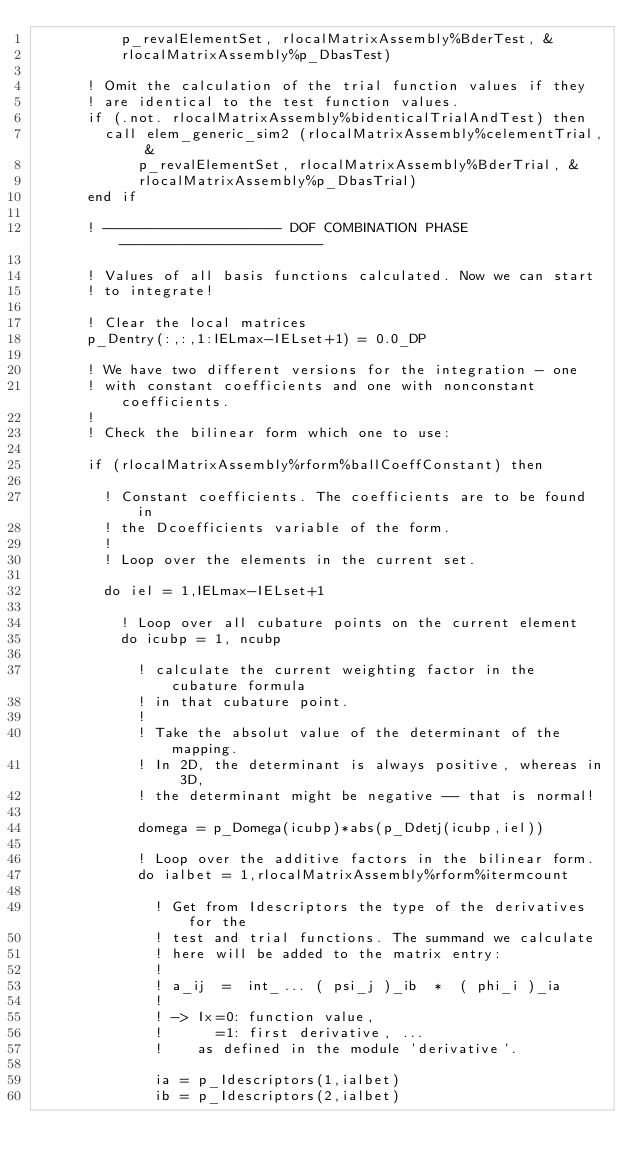Convert code to text. <code><loc_0><loc_0><loc_500><loc_500><_FORTRAN_>          p_revalElementSet, rlocalMatrixAssembly%BderTest, &
          rlocalMatrixAssembly%p_DbasTest)
      
      ! Omit the calculation of the trial function values if they
      ! are identical to the test function values.
      if (.not. rlocalMatrixAssembly%bidenticalTrialAndTest) then
        call elem_generic_sim2 (rlocalMatrixAssembly%celementTrial, &
            p_revalElementSet, rlocalMatrixAssembly%BderTrial, &
            rlocalMatrixAssembly%p_DbasTrial)
      end if
      
      ! --------------------- DOF COMBINATION PHASE ------------------------
      
      ! Values of all basis functions calculated. Now we can start
      ! to integrate!

      ! Clear the local matrices
      p_Dentry(:,:,1:IELmax-IELset+1) = 0.0_DP
      
      ! We have two different versions for the integration - one
      ! with constant coefficients and one with nonconstant coefficients.
      !
      ! Check the bilinear form which one to use:
      
      if (rlocalMatrixAssembly%rform%ballCoeffConstant) then
      
        ! Constant coefficients. The coefficients are to be found in
        ! the Dcoefficients variable of the form.
        !
        ! Loop over the elements in the current set.

        do iel = 1,IELmax-IELset+1
          
          ! Loop over all cubature points on the current element
          do icubp = 1, ncubp

            ! calculate the current weighting factor in the cubature formula
            ! in that cubature point.
            !
            ! Take the absolut value of the determinant of the mapping.
            ! In 2D, the determinant is always positive, whereas in 3D,
            ! the determinant might be negative -- that is normal!

            domega = p_Domega(icubp)*abs(p_Ddetj(icubp,iel))

            ! Loop over the additive factors in the bilinear form.
            do ialbet = 1,rlocalMatrixAssembly%rform%itermcount
            
              ! Get from Idescriptors the type of the derivatives for the 
              ! test and trial functions. The summand we calculate
              ! here will be added to the matrix entry:
              !
              ! a_ij  =  int_... ( psi_j )_ib  *  ( phi_i )_ia
              !
              ! -> Ix=0: function value, 
              !      =1: first derivative, ...
              !    as defined in the module 'derivative'.
              
              ia = p_Idescriptors(1,ialbet)
              ib = p_Idescriptors(2,ialbet)
              </code> 